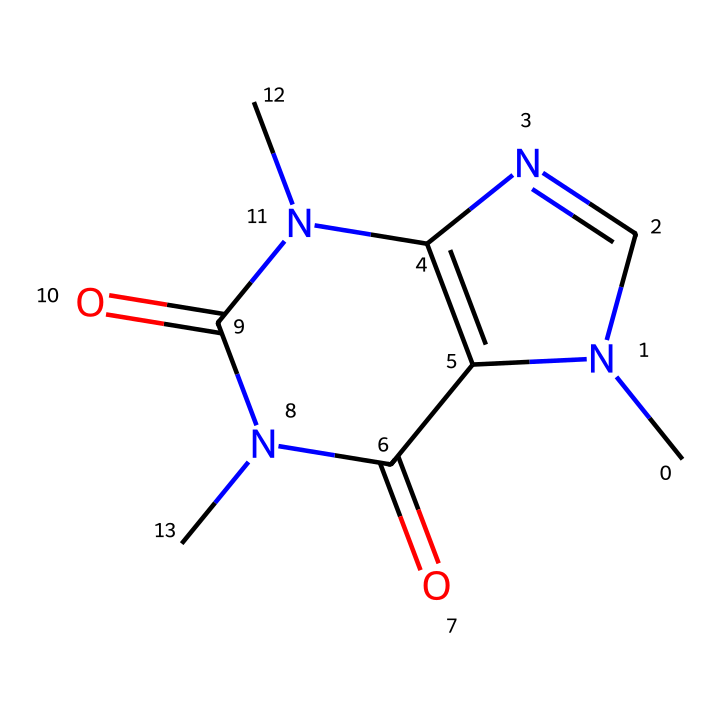How many nitrogen atoms are in this chemical structure? By examining the SMILES representation, we can identify the number of nitrogen (N) atoms present. In the provided SMILES, there are two occurrences of 'N', indicating two nitrogen atoms.
Answer: 2 What is the primary type of functional group present in caffeine? Analyzing the structure, caffeine contains multiple carbonyl (C=O) groups, which are indicative of amides in its functional groups.
Answer: amide How many rings are present in the caffeine structure? The visual examination of the structure indicates two fused rings, characteristic of the purine base structure. Each ring can be counted from the combined atoms in the cyclic arrangement.
Answer: 2 Is caffeine a base, acid, or neutral? The presence of nitrogen atoms and their ability to accept protons within the structure designates caffeine as a base in the context of acid-base chemistry.
Answer: base What is the total number of carbon atoms in the caffeine molecule? A close examination of the carbon atoms represented by 'C' in the SMILES shows there are 8 carbon atoms present in the structure.
Answer: 8 Which type of molecule is caffeine predominantly classified under? Caffeine is predominantly classified as an alkaloid, which is a nitrogen-containing compound that has significant physiological effects. The structure supports this classification due to the presence of nitrogen.
Answer: alkaloid What is the molecular formula of caffeine derived from the structure? From the number of each type of atom identified in the structure: C: 8, H: 10, N: 4, O: 2; thus, the molecular formula of caffeine can be calculated to be C8H10N4O2.
Answer: C8H10N4O2 